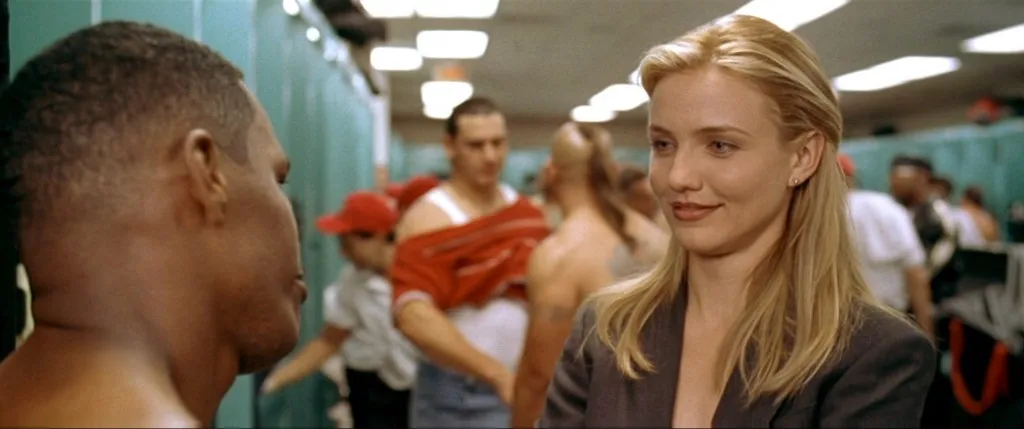Imagine a backstory for these characters outside of a sports context. In an alternative setting, the woman could be envisioned as a high-powered legal or business professional engaged in a consultative discussion with the man, who appears to be her client or colleague. Their interaction, marked by professionalism and mutual respect, suggests they are at a pivotal moment, possibly making a significant decision or strategizing about a crucial project. The serious yet respectful nature of their conversation hints at the weight of their discussion and the impact it might have on their professional relationship and future outcomes. 